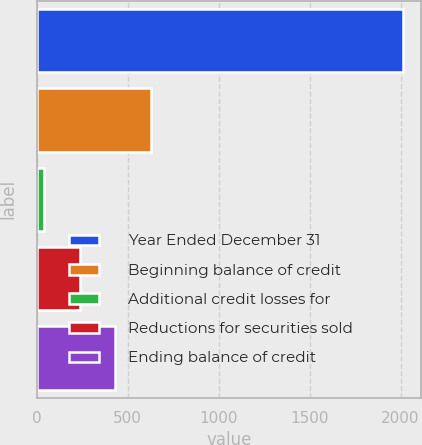<chart> <loc_0><loc_0><loc_500><loc_500><bar_chart><fcel>Year Ended December 31<fcel>Beginning balance of credit<fcel>Additional credit losses for<fcel>Reductions for securities sold<fcel>Ending balance of credit<nl><fcel>2011<fcel>630.6<fcel>39<fcel>236.2<fcel>433.4<nl></chart> 